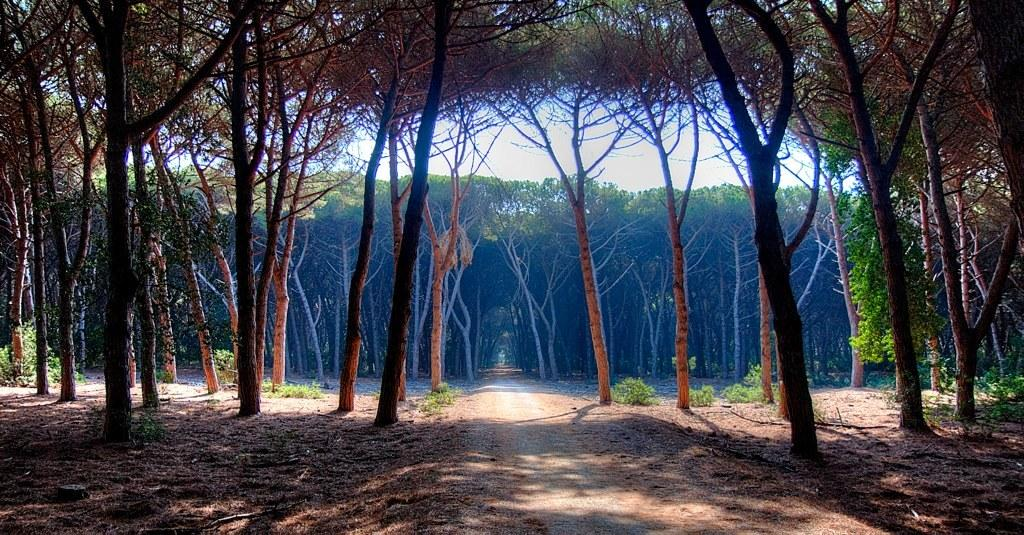What type of vegetation can be seen in the image? There are trees in the image. What is visible at the top of the image? The sky is visible at the top of the image. What object can be seen in the middle of the image? There is a rope in the middle of the image. What type of cabbage is hanging from the rope in the image? There is no cabbage present in the image; it only features trees, the sky, and a rope. What type of drug can be seen in the image? There is no drug present in the image. 